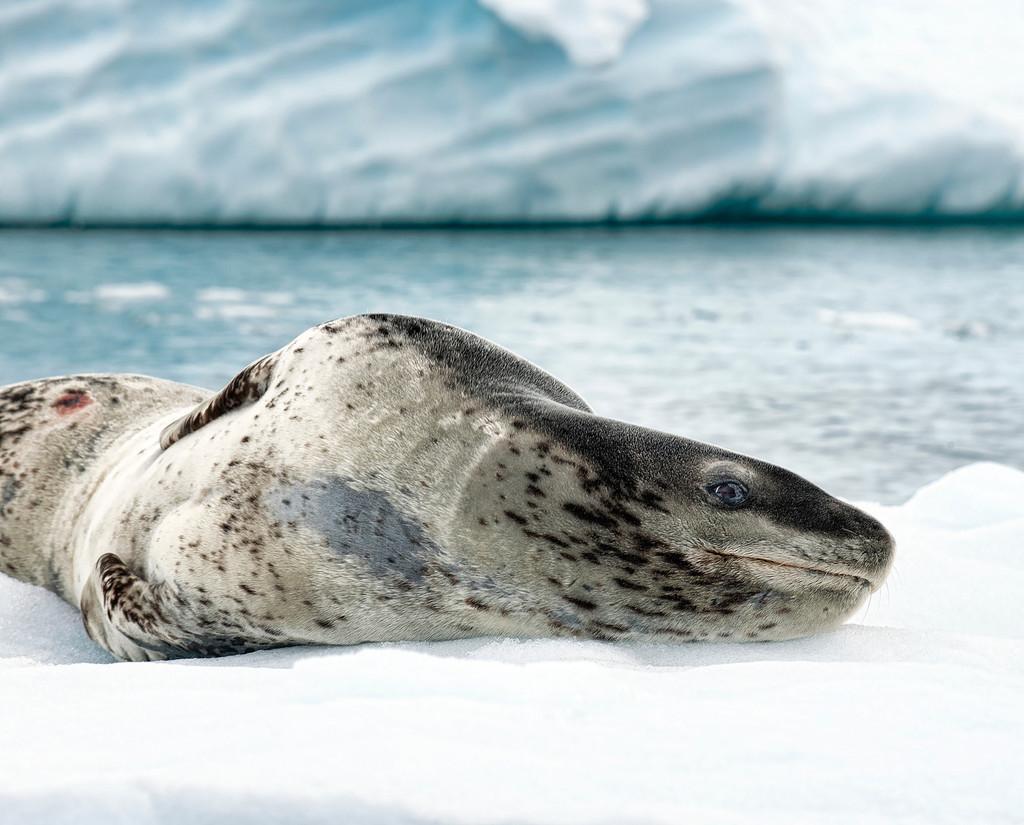Can you describe this image briefly? In the foreground of the picture there is a seal on the ice. The background is blurred. In the background there is water and there is a iceberg. 